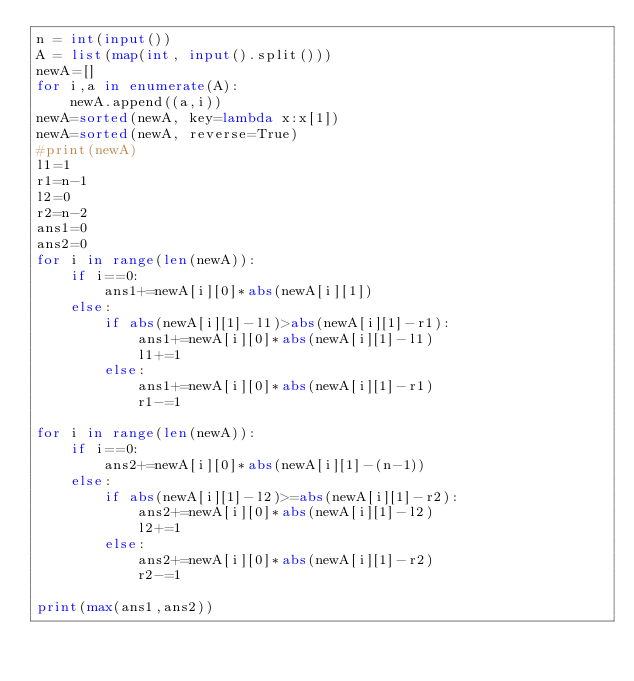Convert code to text. <code><loc_0><loc_0><loc_500><loc_500><_Python_>n = int(input())
A = list(map(int, input().split()))
newA=[]
for i,a in enumerate(A):
    newA.append((a,i))
newA=sorted(newA, key=lambda x:x[1])
newA=sorted(newA, reverse=True)
#print(newA)
l1=1
r1=n-1
l2=0
r2=n-2
ans1=0
ans2=0
for i in range(len(newA)):
    if i==0:
        ans1+=newA[i][0]*abs(newA[i][1])
    else:
        if abs(newA[i][1]-l1)>abs(newA[i][1]-r1):
            ans1+=newA[i][0]*abs(newA[i][1]-l1)
            l1+=1
        else:
            ans1+=newA[i][0]*abs(newA[i][1]-r1)
            r1-=1

for i in range(len(newA)):
    if i==0:
        ans2+=newA[i][0]*abs(newA[i][1]-(n-1))
    else:
        if abs(newA[i][1]-l2)>=abs(newA[i][1]-r2):
            ans2+=newA[i][0]*abs(newA[i][1]-l2)
            l2+=1
        else:
            ans2+=newA[i][0]*abs(newA[i][1]-r2)
            r2-=1

print(max(ans1,ans2))</code> 